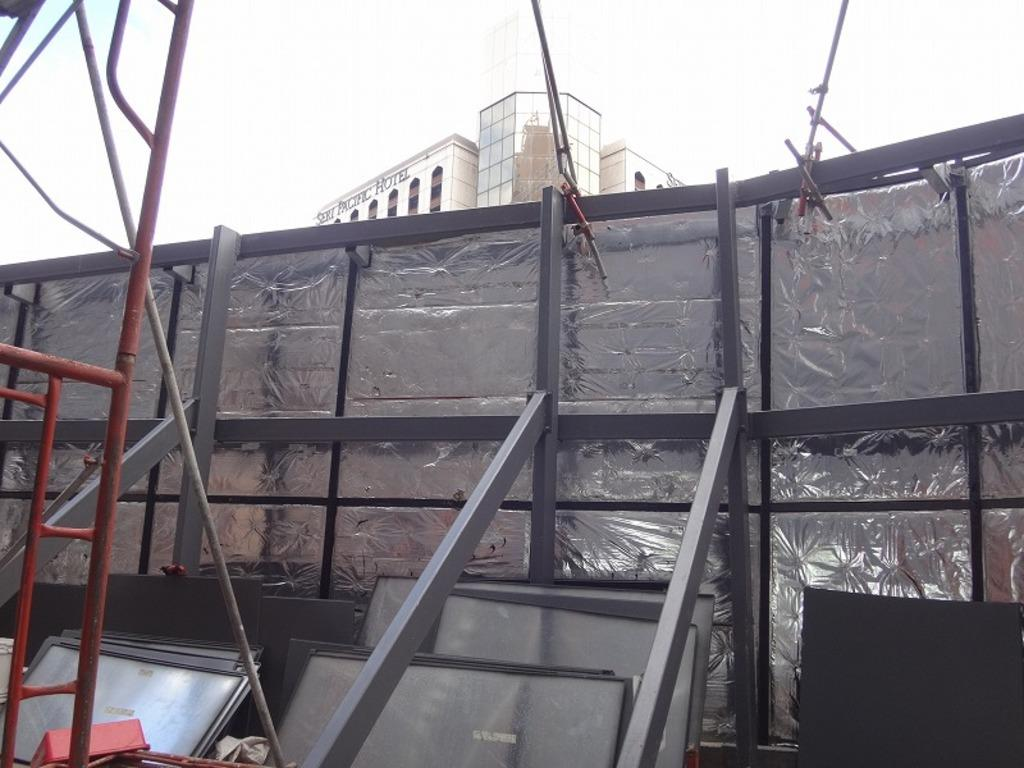What type of material is used for the planks in the foreground of the image? The planks in the foreground of the image are made of metal. What other objects can be seen in the foreground of the image? There are poles and wall-like structures in the foreground of the image. What is visible in the background of the image? There is a building and the sky visible in the background of the image. What type of toothbrush is recommended by the expert in the image? There is no toothbrush or expert present in the image. What type of relation can be seen between the metal planks and the poles in the image? There is no relation between the metal planks and the poles in the image; they are separate objects. 